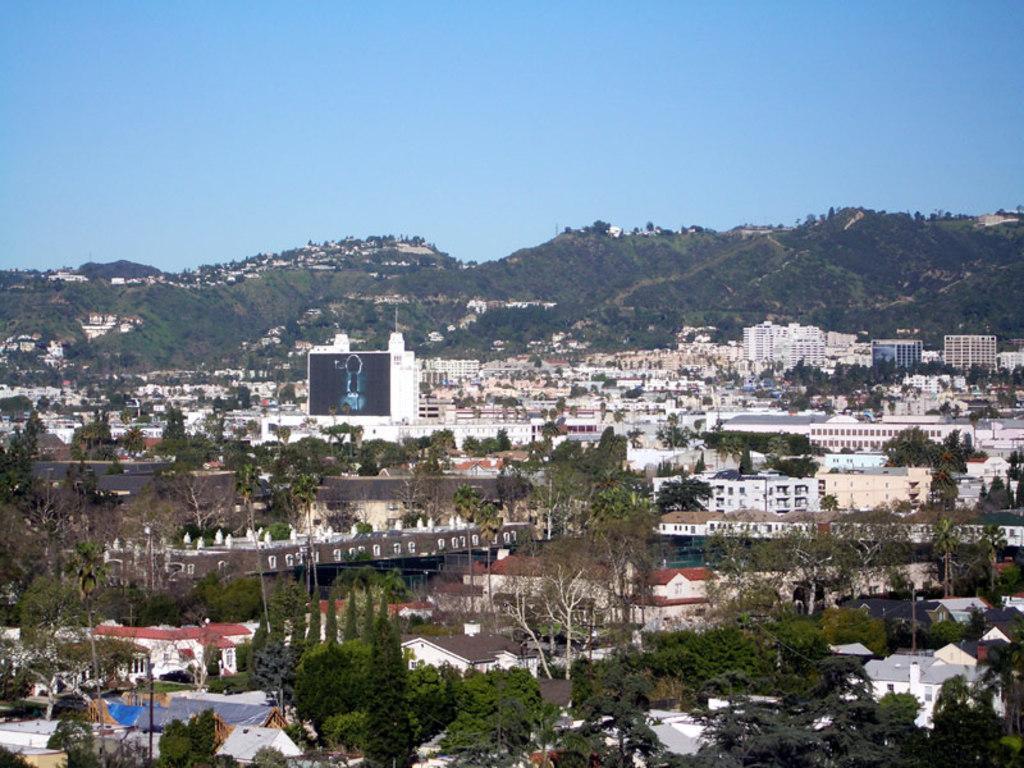Could you give a brief overview of what you see in this image? In this image we can see houses, trees, mountains, plants, light poles and in the background we can see the sky. 